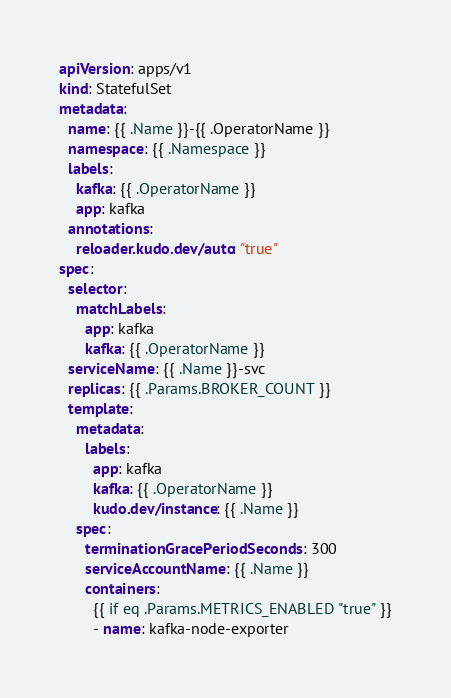<code> <loc_0><loc_0><loc_500><loc_500><_YAML_>apiVersion: apps/v1
kind: StatefulSet
metadata:
  name: {{ .Name }}-{{ .OperatorName }}
  namespace: {{ .Namespace }}
  labels:
    kafka: {{ .OperatorName }}
    app: kafka
  annotations:
    reloader.kudo.dev/auto: "true"
spec:
  selector:
    matchLabels:
      app: kafka
      kafka: {{ .OperatorName }}
  serviceName: {{ .Name }}-svc
  replicas: {{ .Params.BROKER_COUNT }}
  template:
    metadata:
      labels:
        app: kafka
        kafka: {{ .OperatorName }}
        kudo.dev/instance: {{ .Name }}
    spec:
      terminationGracePeriodSeconds: 300
      serviceAccountName: {{ .Name }}
      containers:
        {{ if eq .Params.METRICS_ENABLED "true" }}
        - name: kafka-node-exporter</code> 